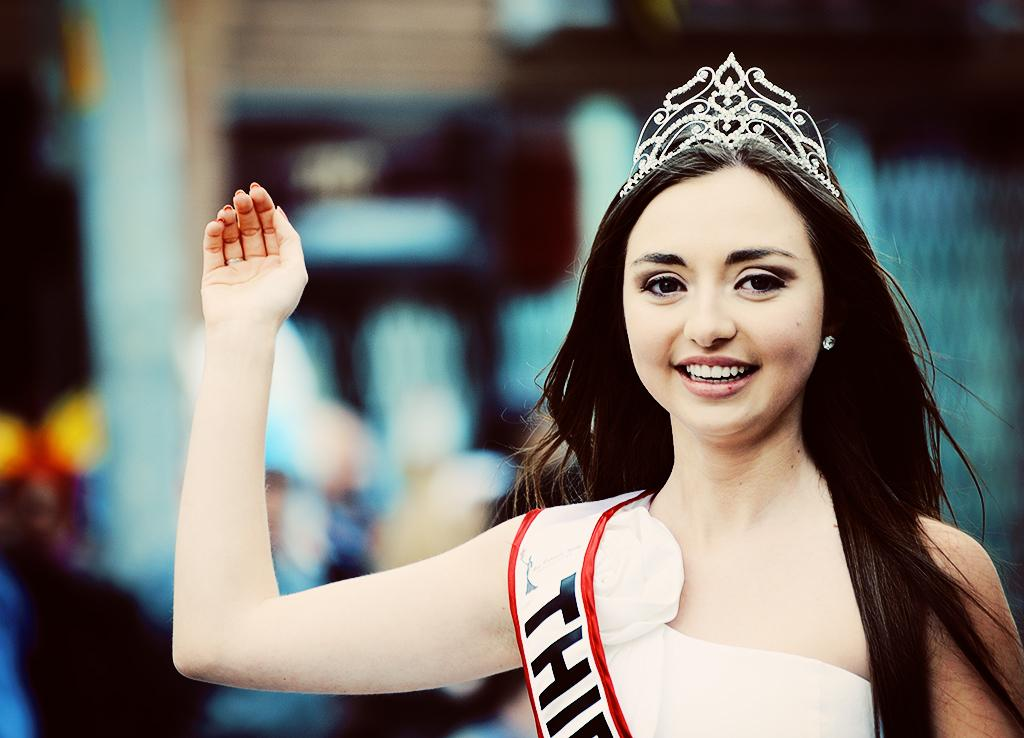Who is the main subject in the image? There is a lady in the image. What is the lady wearing on her head? The lady is wearing a crown on her head. What book is the lady reading in the image? There is no book or reading activity depicted in the image. 